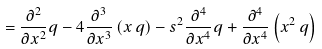Convert formula to latex. <formula><loc_0><loc_0><loc_500><loc_500>= \frac { \partial ^ { 2 } } { \partial x ^ { 2 } } q - 4 \frac { \partial ^ { 3 } } { \partial x ^ { 3 } } \left ( x \, q \right ) - s ^ { 2 } \frac { \partial ^ { 4 } } { \partial x ^ { 4 } } q + \frac { \partial ^ { 4 } } { \partial x ^ { 4 } } \left ( x ^ { 2 } \, q \right )</formula> 